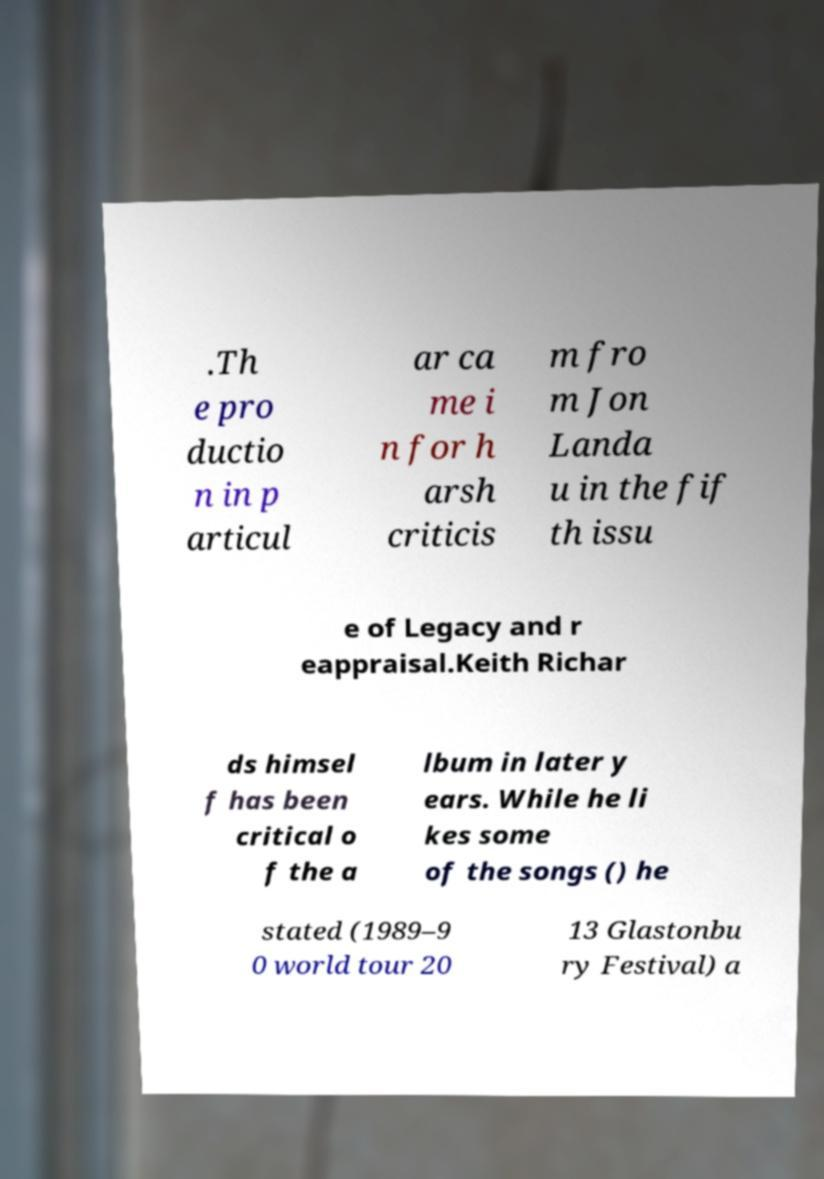Can you read and provide the text displayed in the image?This photo seems to have some interesting text. Can you extract and type it out for me? .Th e pro ductio n in p articul ar ca me i n for h arsh criticis m fro m Jon Landa u in the fif th issu e of Legacy and r eappraisal.Keith Richar ds himsel f has been critical o f the a lbum in later y ears. While he li kes some of the songs () he stated (1989–9 0 world tour 20 13 Glastonbu ry Festival) a 